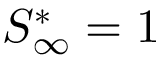Convert formula to latex. <formula><loc_0><loc_0><loc_500><loc_500>S _ { \infty } ^ { * } = 1</formula> 